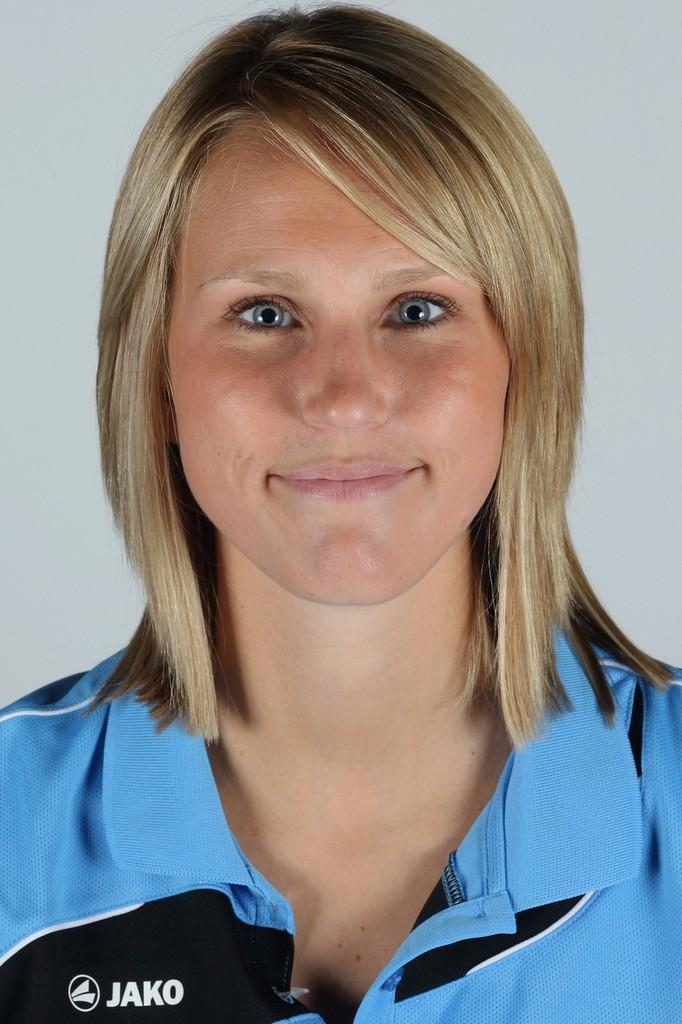<image>
Share a concise interpretation of the image provided. A young, blonde woman, slightly smiling is wearing a blue and black, JAKO athletic shirt. 